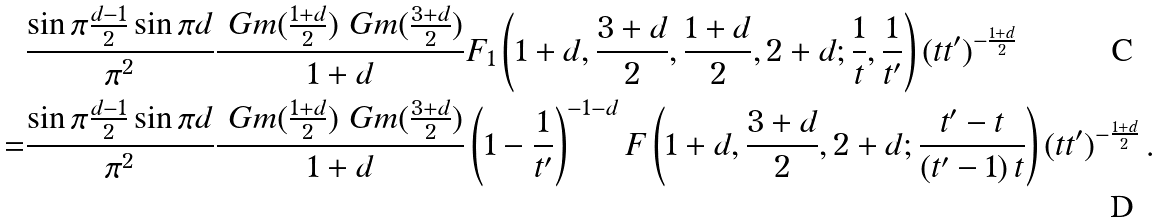<formula> <loc_0><loc_0><loc_500><loc_500>& \frac { \sin \pi \frac { d - 1 } { 2 } \sin \pi d } { \pi ^ { 2 } } \frac { \ G m ( \frac { 1 + d } { 2 } ) \ G m ( \frac { 3 + d } { 2 } ) } { 1 + d } F _ { 1 } \left ( 1 + d , \frac { 3 + d } { 2 } , \frac { 1 + d } { 2 } , 2 + d ; \frac { 1 } { t } , \frac { 1 } { t ^ { \prime } } \right ) ( t t ^ { \prime } ) ^ { - \frac { 1 + d } { 2 } } \\ = & \frac { \sin \pi \frac { d - 1 } { 2 } \sin \pi d } { \pi ^ { 2 } } \frac { \ G m ( \frac { 1 + d } { 2 } ) \ G m ( \frac { 3 + d } { 2 } ) } { 1 + d } \left ( 1 - \frac { 1 } { t ^ { \prime } } \right ) ^ { - 1 - d } F \left ( 1 + d , \frac { 3 + d } { 2 } , 2 + d ; \frac { t ^ { \prime } - t } { \left ( t ^ { \prime } - 1 \right ) t } \right ) ( t t ^ { \prime } ) ^ { - \frac { 1 + d } { 2 } } \, .</formula> 